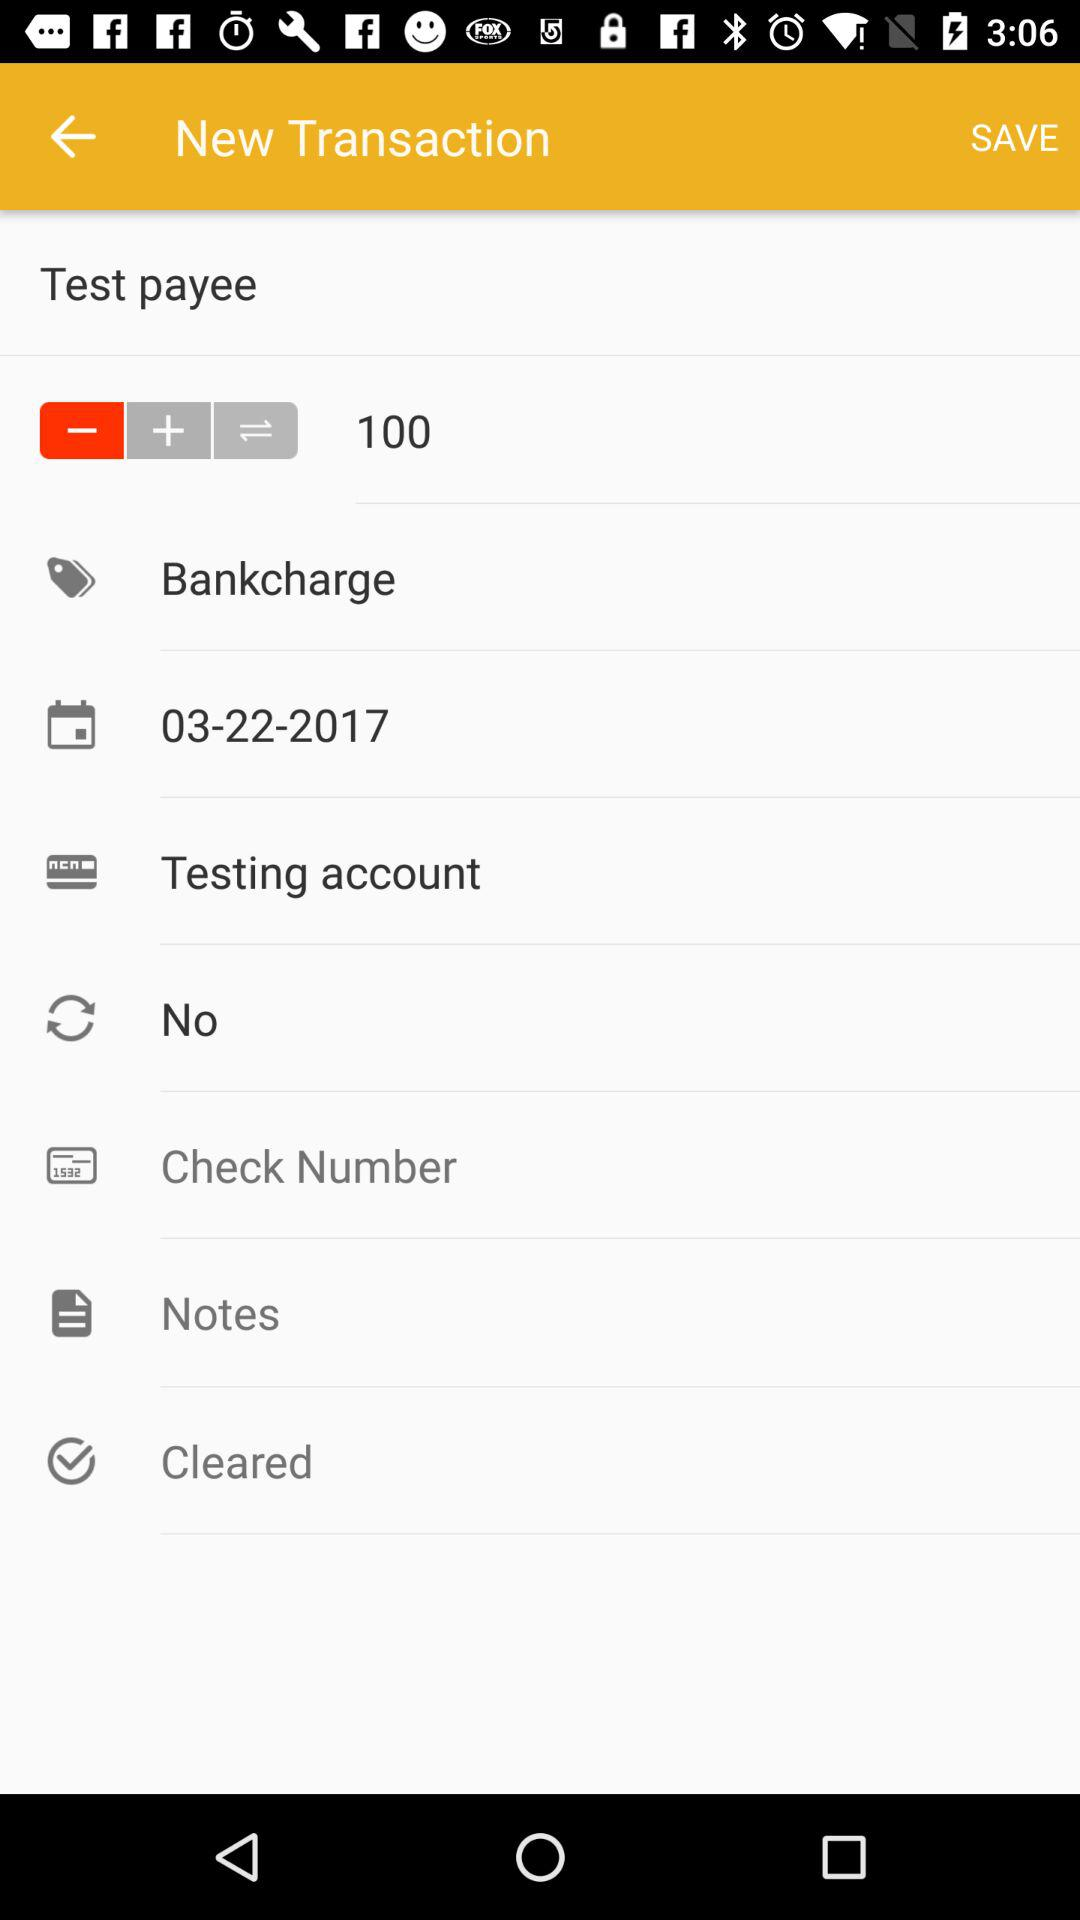Which date is selected from the calendar? The selected date is March 22, 2017. 